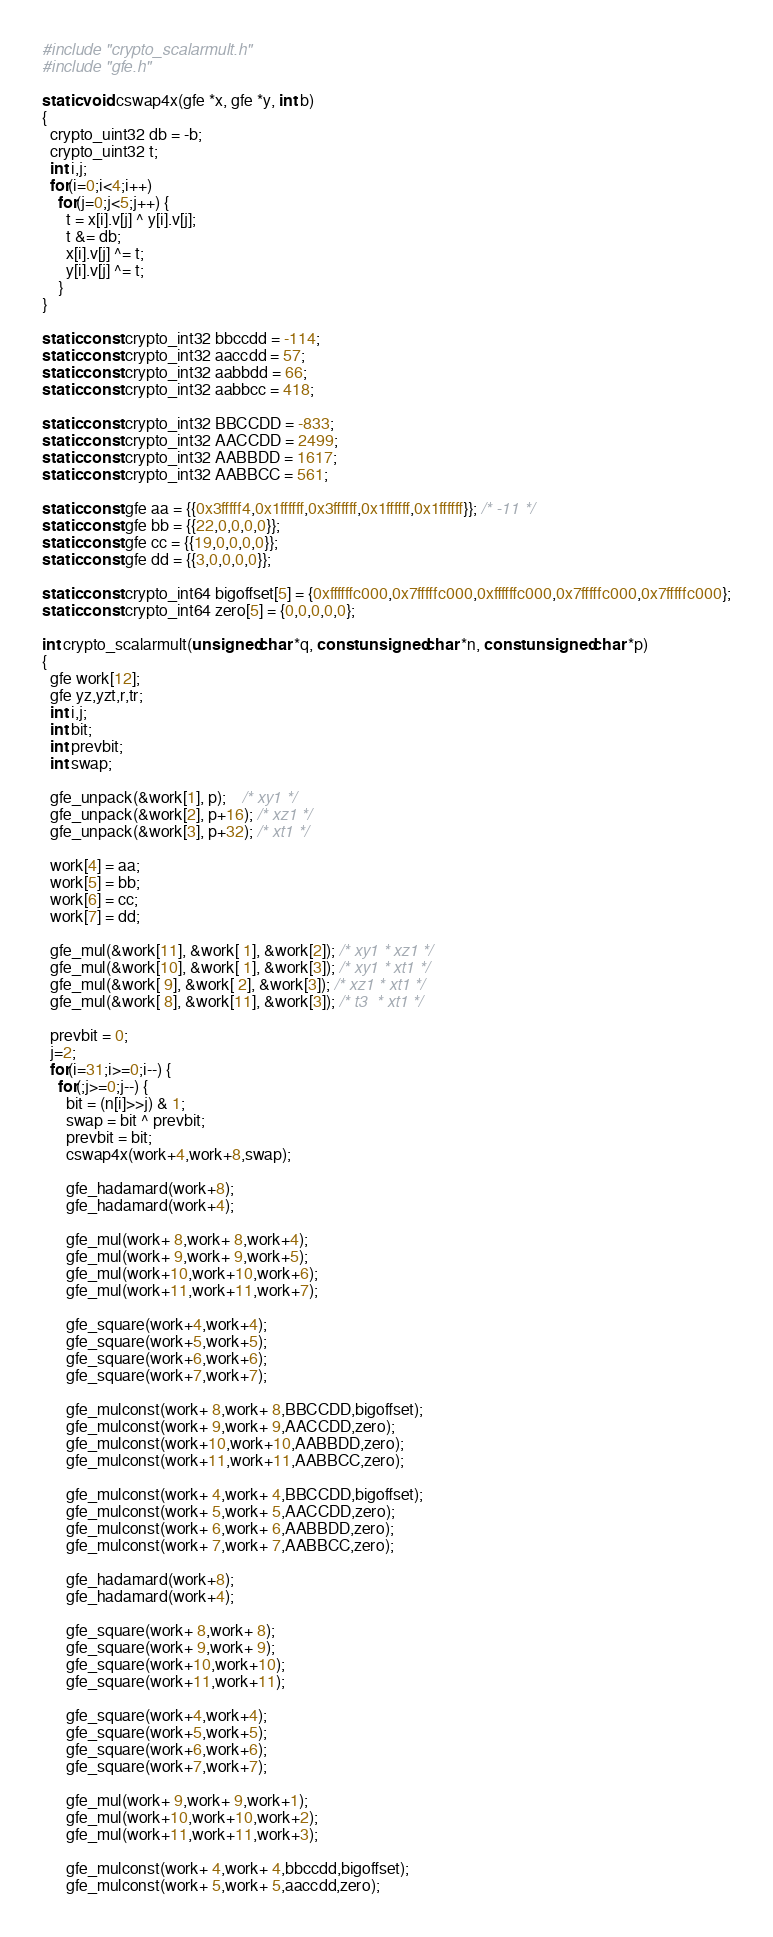<code> <loc_0><loc_0><loc_500><loc_500><_C_>#include "crypto_scalarmult.h"
#include "gfe.h"

static void cswap4x(gfe *x, gfe *y, int b)
{
  crypto_uint32 db = -b;
  crypto_uint32 t;
  int i,j;
  for(i=0;i<4;i++)
    for(j=0;j<5;j++) {
      t = x[i].v[j] ^ y[i].v[j];
      t &= db;
      x[i].v[j] ^= t;
      y[i].v[j] ^= t;
    }
}
  
static const crypto_int32 bbccdd = -114;
static const crypto_int32 aaccdd = 57;
static const crypto_int32 aabbdd = 66;
static const crypto_int32 aabbcc = 418;

static const crypto_int32 BBCCDD = -833;
static const crypto_int32 AACCDD = 2499;
static const crypto_int32 AABBDD = 1617;
static const crypto_int32 AABBCC = 561;

static const gfe aa = {{0x3fffff4,0x1ffffff,0x3ffffff,0x1ffffff,0x1ffffff}}; /* -11 */
static const gfe bb = {{22,0,0,0,0}};
static const gfe cc = {{19,0,0,0,0}};
static const gfe dd = {{3,0,0,0,0}};

static const crypto_int64 bigoffset[5] = {0xffffffc000,0x7fffffc000,0xffffffc000,0x7fffffc000,0x7fffffc000};
static const crypto_int64 zero[5] = {0,0,0,0,0};

int crypto_scalarmult(unsigned char *q, const unsigned char *n, const unsigned char *p)
{
  gfe work[12];
  gfe yz,yzt,r,tr;
  int i,j;
  int bit;
  int prevbit;
  int swap;

  gfe_unpack(&work[1], p);    /* xy1 */
  gfe_unpack(&work[2], p+16); /* xz1 */
  gfe_unpack(&work[3], p+32); /* xt1 */

  work[4] = aa;
  work[5] = bb;
  work[6] = cc;
  work[7] = dd;

  gfe_mul(&work[11], &work[ 1], &work[2]); /* xy1 * xz1 */
  gfe_mul(&work[10], &work[ 1], &work[3]); /* xy1 * xt1 */
  gfe_mul(&work[ 9], &work[ 2], &work[3]); /* xz1 * xt1 */
  gfe_mul(&work[ 8], &work[11], &work[3]); /* t3  * xt1 */

  prevbit = 0;
  j=2;
  for(i=31;i>=0;i--) {
    for(;j>=0;j--) {
      bit = (n[i]>>j) & 1;
      swap = bit ^ prevbit;
      prevbit = bit;
      cswap4x(work+4,work+8,swap);

      gfe_hadamard(work+8);
      gfe_hadamard(work+4);
      
      gfe_mul(work+ 8,work+ 8,work+4);
      gfe_mul(work+ 9,work+ 9,work+5);
      gfe_mul(work+10,work+10,work+6);
      gfe_mul(work+11,work+11,work+7);
     
      gfe_square(work+4,work+4);
      gfe_square(work+5,work+5);
      gfe_square(work+6,work+6);
      gfe_square(work+7,work+7);
    
      gfe_mulconst(work+ 8,work+ 8,BBCCDD,bigoffset);
      gfe_mulconst(work+ 9,work+ 9,AACCDD,zero);
      gfe_mulconst(work+10,work+10,AABBDD,zero);
      gfe_mulconst(work+11,work+11,AABBCC,zero);
    
      gfe_mulconst(work+ 4,work+ 4,BBCCDD,bigoffset);
      gfe_mulconst(work+ 5,work+ 5,AACCDD,zero);
      gfe_mulconst(work+ 6,work+ 6,AABBDD,zero);
      gfe_mulconst(work+ 7,work+ 7,AABBCC,zero);
    
      gfe_hadamard(work+8);
      gfe_hadamard(work+4);
    
      gfe_square(work+ 8,work+ 8);
      gfe_square(work+ 9,work+ 9);
      gfe_square(work+10,work+10);
      gfe_square(work+11,work+11);
      
      gfe_square(work+4,work+4);
      gfe_square(work+5,work+5);
      gfe_square(work+6,work+6);
      gfe_square(work+7,work+7);
      
      gfe_mul(work+ 9,work+ 9,work+1);
      gfe_mul(work+10,work+10,work+2);
      gfe_mul(work+11,work+11,work+3);
      
      gfe_mulconst(work+ 4,work+ 4,bbccdd,bigoffset);
      gfe_mulconst(work+ 5,work+ 5,aaccdd,zero);</code> 